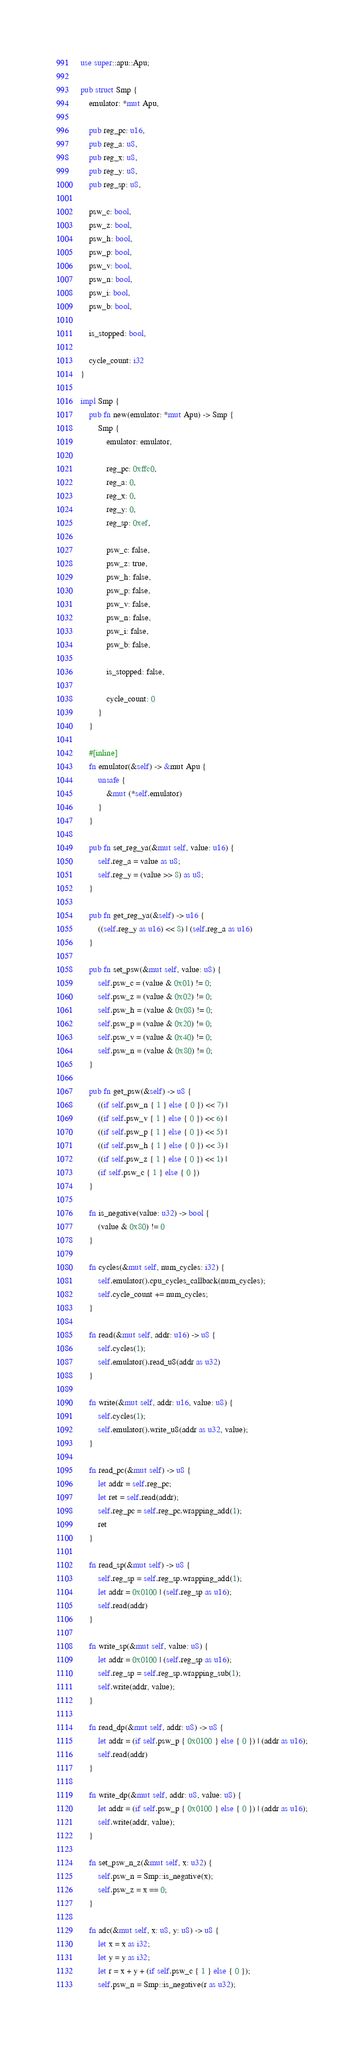<code> <loc_0><loc_0><loc_500><loc_500><_Rust_>use super::apu::Apu;

pub struct Smp {
    emulator: *mut Apu,

    pub reg_pc: u16,
    pub reg_a: u8,
    pub reg_x: u8,
    pub reg_y: u8,
    pub reg_sp: u8,

    psw_c: bool,
    psw_z: bool,
    psw_h: bool,
    psw_p: bool,
    psw_v: bool,
    psw_n: bool,
    psw_i: bool,
    psw_b: bool,

    is_stopped: bool,

    cycle_count: i32
}

impl Smp {
    pub fn new(emulator: *mut Apu) -> Smp {
        Smp {
            emulator: emulator,

            reg_pc: 0xffc0,
            reg_a: 0,
            reg_x: 0,
            reg_y: 0,
            reg_sp: 0xef,

            psw_c: false,
            psw_z: true,
            psw_h: false,
            psw_p: false,
            psw_v: false,
            psw_n: false,
            psw_i: false,
            psw_b: false,

            is_stopped: false,

            cycle_count: 0
        }
    }

    #[inline]
    fn emulator(&self) -> &mut Apu {
        unsafe {
            &mut (*self.emulator)
        }
    }

    pub fn set_reg_ya(&mut self, value: u16) {
        self.reg_a = value as u8;
        self.reg_y = (value >> 8) as u8;
    }

    pub fn get_reg_ya(&self) -> u16 {
        ((self.reg_y as u16) << 8) | (self.reg_a as u16)
    }

    pub fn set_psw(&mut self, value: u8) {
        self.psw_c = (value & 0x01) != 0;
        self.psw_z = (value & 0x02) != 0;
        self.psw_h = (value & 0x08) != 0;
        self.psw_p = (value & 0x20) != 0;
        self.psw_v = (value & 0x40) != 0;
        self.psw_n = (value & 0x80) != 0;
    }

    pub fn get_psw(&self) -> u8 {
        ((if self.psw_n { 1 } else { 0 }) << 7) |
        ((if self.psw_v { 1 } else { 0 }) << 6) |
        ((if self.psw_p { 1 } else { 0 }) << 5) |
        ((if self.psw_h { 1 } else { 0 }) << 3) |
        ((if self.psw_z { 1 } else { 0 }) << 1) |
        (if self.psw_c { 1 } else { 0 })
    }

    fn is_negative(value: u32) -> bool {
        (value & 0x80) != 0
    }

    fn cycles(&mut self, num_cycles: i32) {
        self.emulator().cpu_cycles_callback(num_cycles);
        self.cycle_count += num_cycles;
    }

    fn read(&mut self, addr: u16) -> u8 {
        self.cycles(1);
        self.emulator().read_u8(addr as u32)
    }

    fn write(&mut self, addr: u16, value: u8) {
        self.cycles(1);
        self.emulator().write_u8(addr as u32, value);
    }

    fn read_pc(&mut self) -> u8 {
        let addr = self.reg_pc;
        let ret = self.read(addr);
        self.reg_pc = self.reg_pc.wrapping_add(1);
        ret
    }

    fn read_sp(&mut self) -> u8 {
        self.reg_sp = self.reg_sp.wrapping_add(1);
        let addr = 0x0100 | (self.reg_sp as u16);
        self.read(addr)
    }

    fn write_sp(&mut self, value: u8) {
        let addr = 0x0100 | (self.reg_sp as u16);
        self.reg_sp = self.reg_sp.wrapping_sub(1);
        self.write(addr, value);
    }

    fn read_dp(&mut self, addr: u8) -> u8 {
        let addr = (if self.psw_p { 0x0100 } else { 0 }) | (addr as u16);
        self.read(addr)
    }

    fn write_dp(&mut self, addr: u8, value: u8) {
        let addr = (if self.psw_p { 0x0100 } else { 0 }) | (addr as u16);
        self.write(addr, value);
    }

    fn set_psw_n_z(&mut self, x: u32) {
        self.psw_n = Smp::is_negative(x);
        self.psw_z = x == 0;
    }

    fn adc(&mut self, x: u8, y: u8) -> u8 {
        let x = x as i32;
        let y = y as i32;
        let r = x + y + (if self.psw_c { 1 } else { 0 });
        self.psw_n = Smp::is_negative(r as u32);</code> 